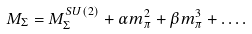Convert formula to latex. <formula><loc_0><loc_0><loc_500><loc_500>M _ { \Sigma } = M _ { \Sigma } ^ { S U ( 2 ) } + \alpha m _ { \pi } ^ { 2 } + \beta m _ { \pi } ^ { 3 } + \dots .</formula> 